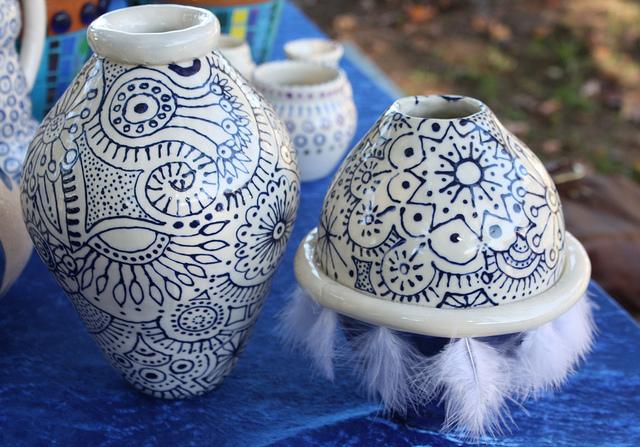Where is the big vase?
Write a very short answer. On left. Are these made from ceramic or glass?
Quick response, please. Ceramic. What color are the vase to the right?
Write a very short answer. Blue and white. 